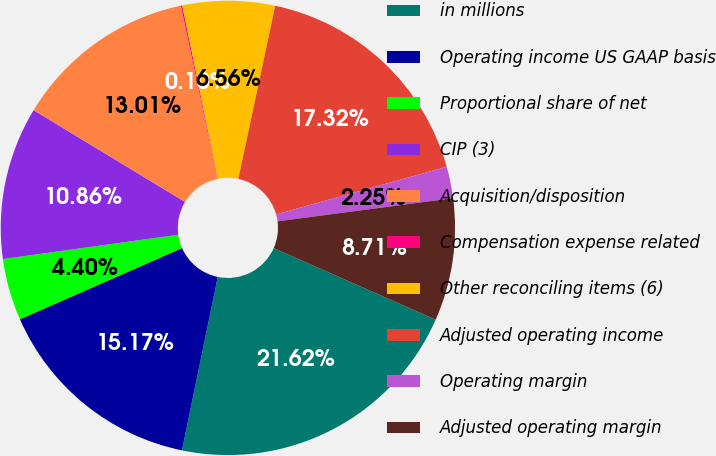<chart> <loc_0><loc_0><loc_500><loc_500><pie_chart><fcel>in millions<fcel>Operating income US GAAP basis<fcel>Proportional share of net<fcel>CIP (3)<fcel>Acquisition/disposition<fcel>Compensation expense related<fcel>Other reconciling items (6)<fcel>Adjusted operating income<fcel>Operating margin<fcel>Adjusted operating margin<nl><fcel>21.62%<fcel>15.17%<fcel>4.4%<fcel>10.86%<fcel>13.01%<fcel>0.1%<fcel>6.56%<fcel>17.32%<fcel>2.25%<fcel>8.71%<nl></chart> 